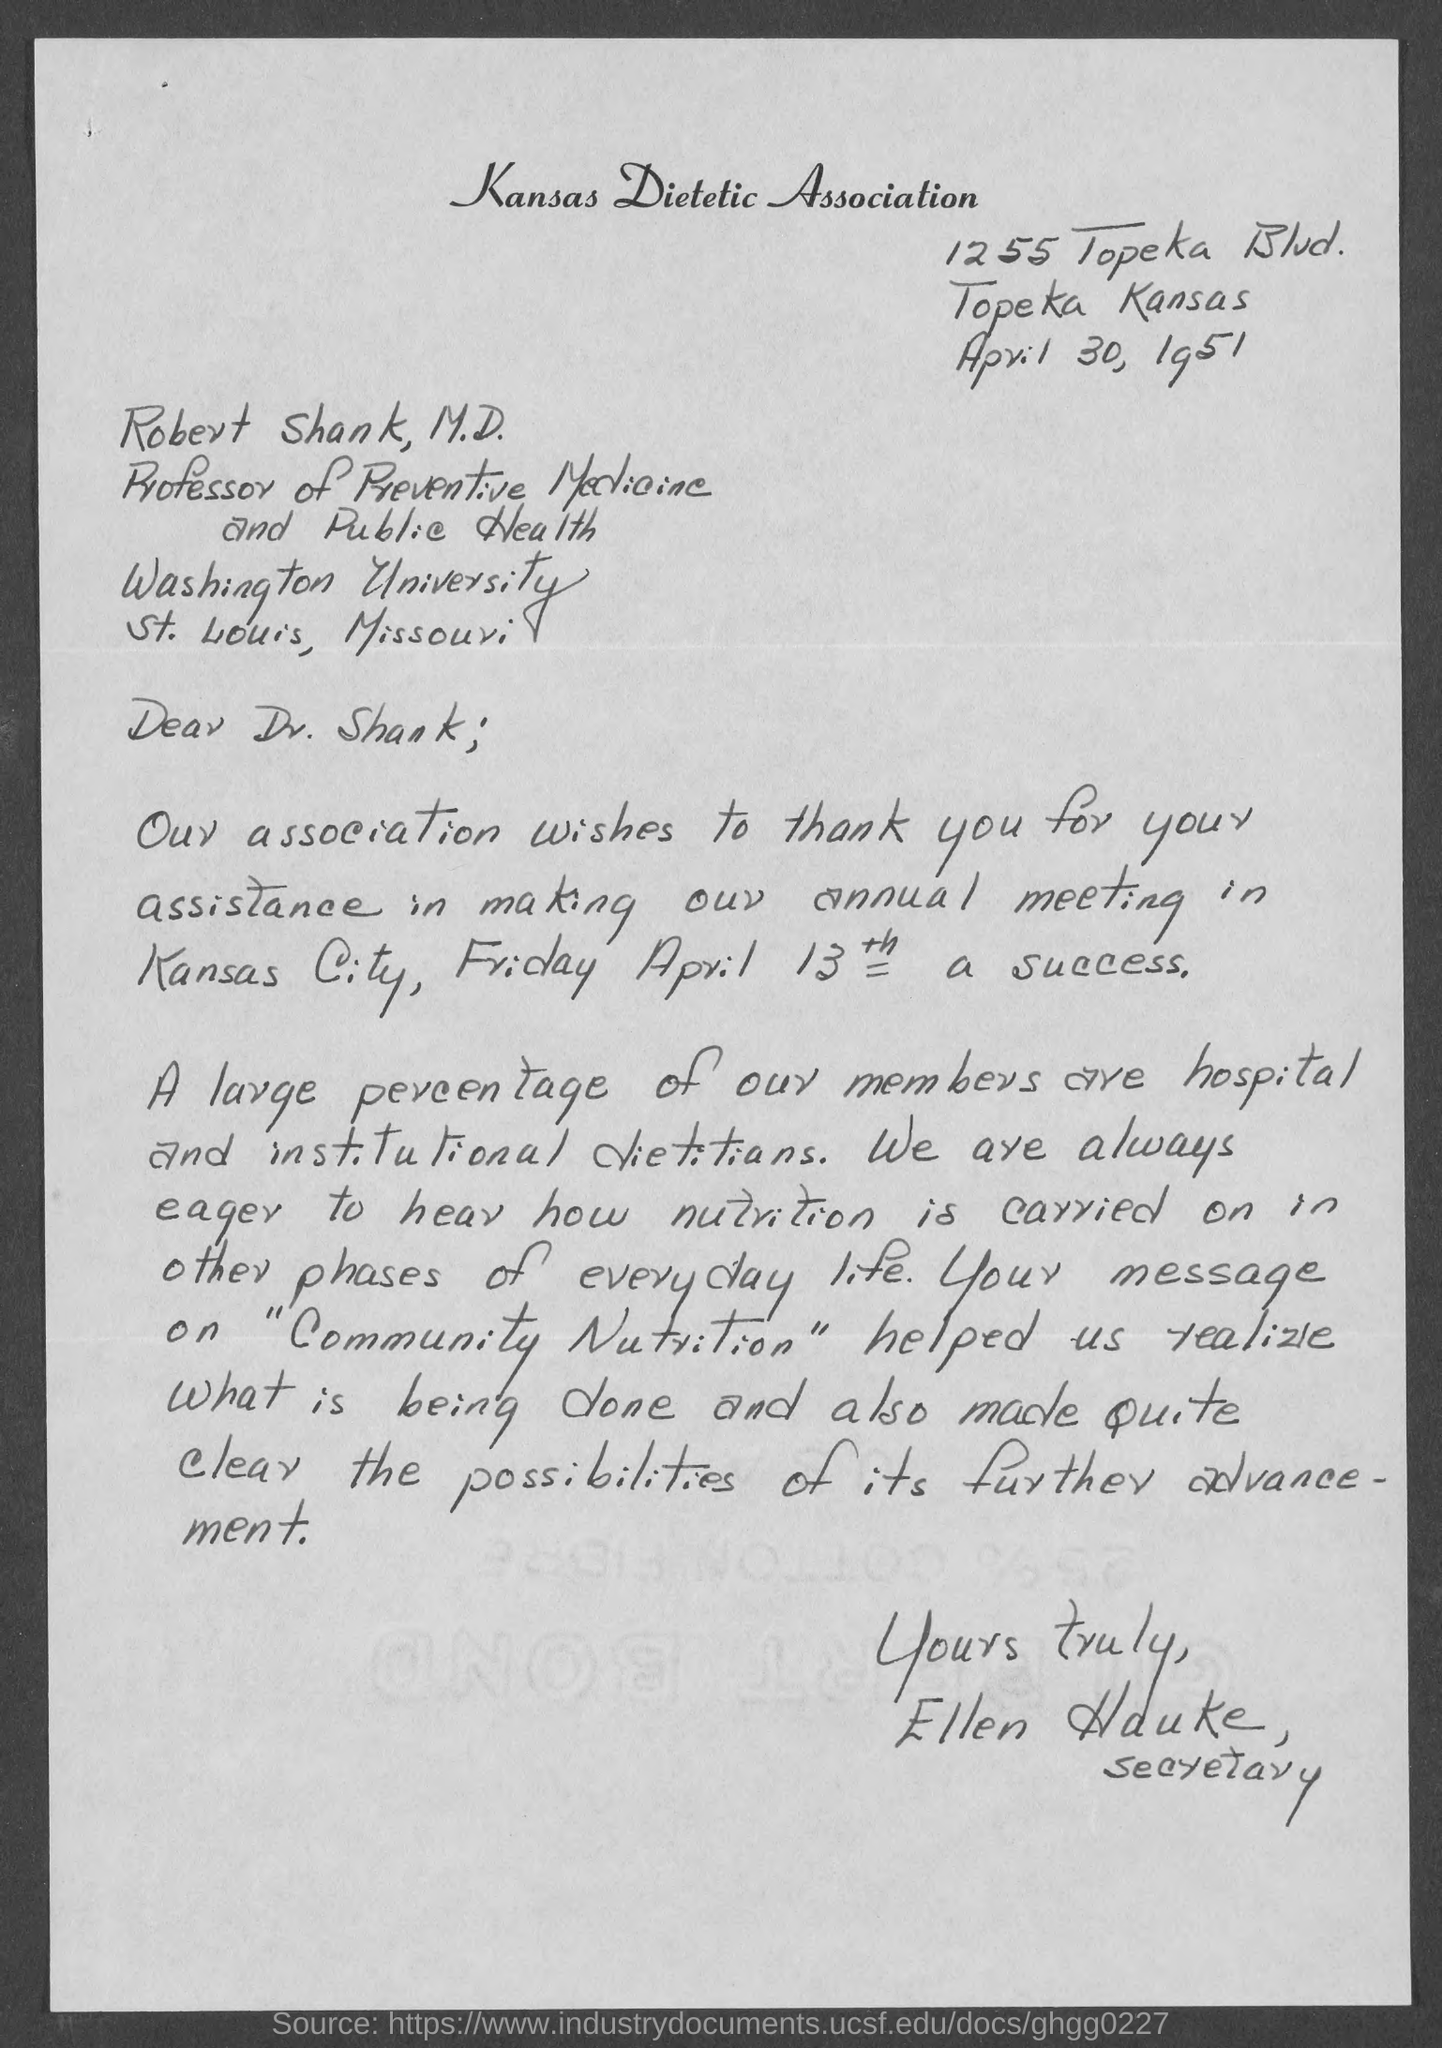Which association is mentioned?
Keep it short and to the point. Kansas dietetic association. To whom is the letter addressed?
Your response must be concise. Robert shank. What is Robert Shank's designation?
Your response must be concise. Professor of preventive medicine and public health. When is the letter dated?
Offer a terse response. April 30, 1951. Who is Ellen Hauke?
Ensure brevity in your answer.  Secretary. 